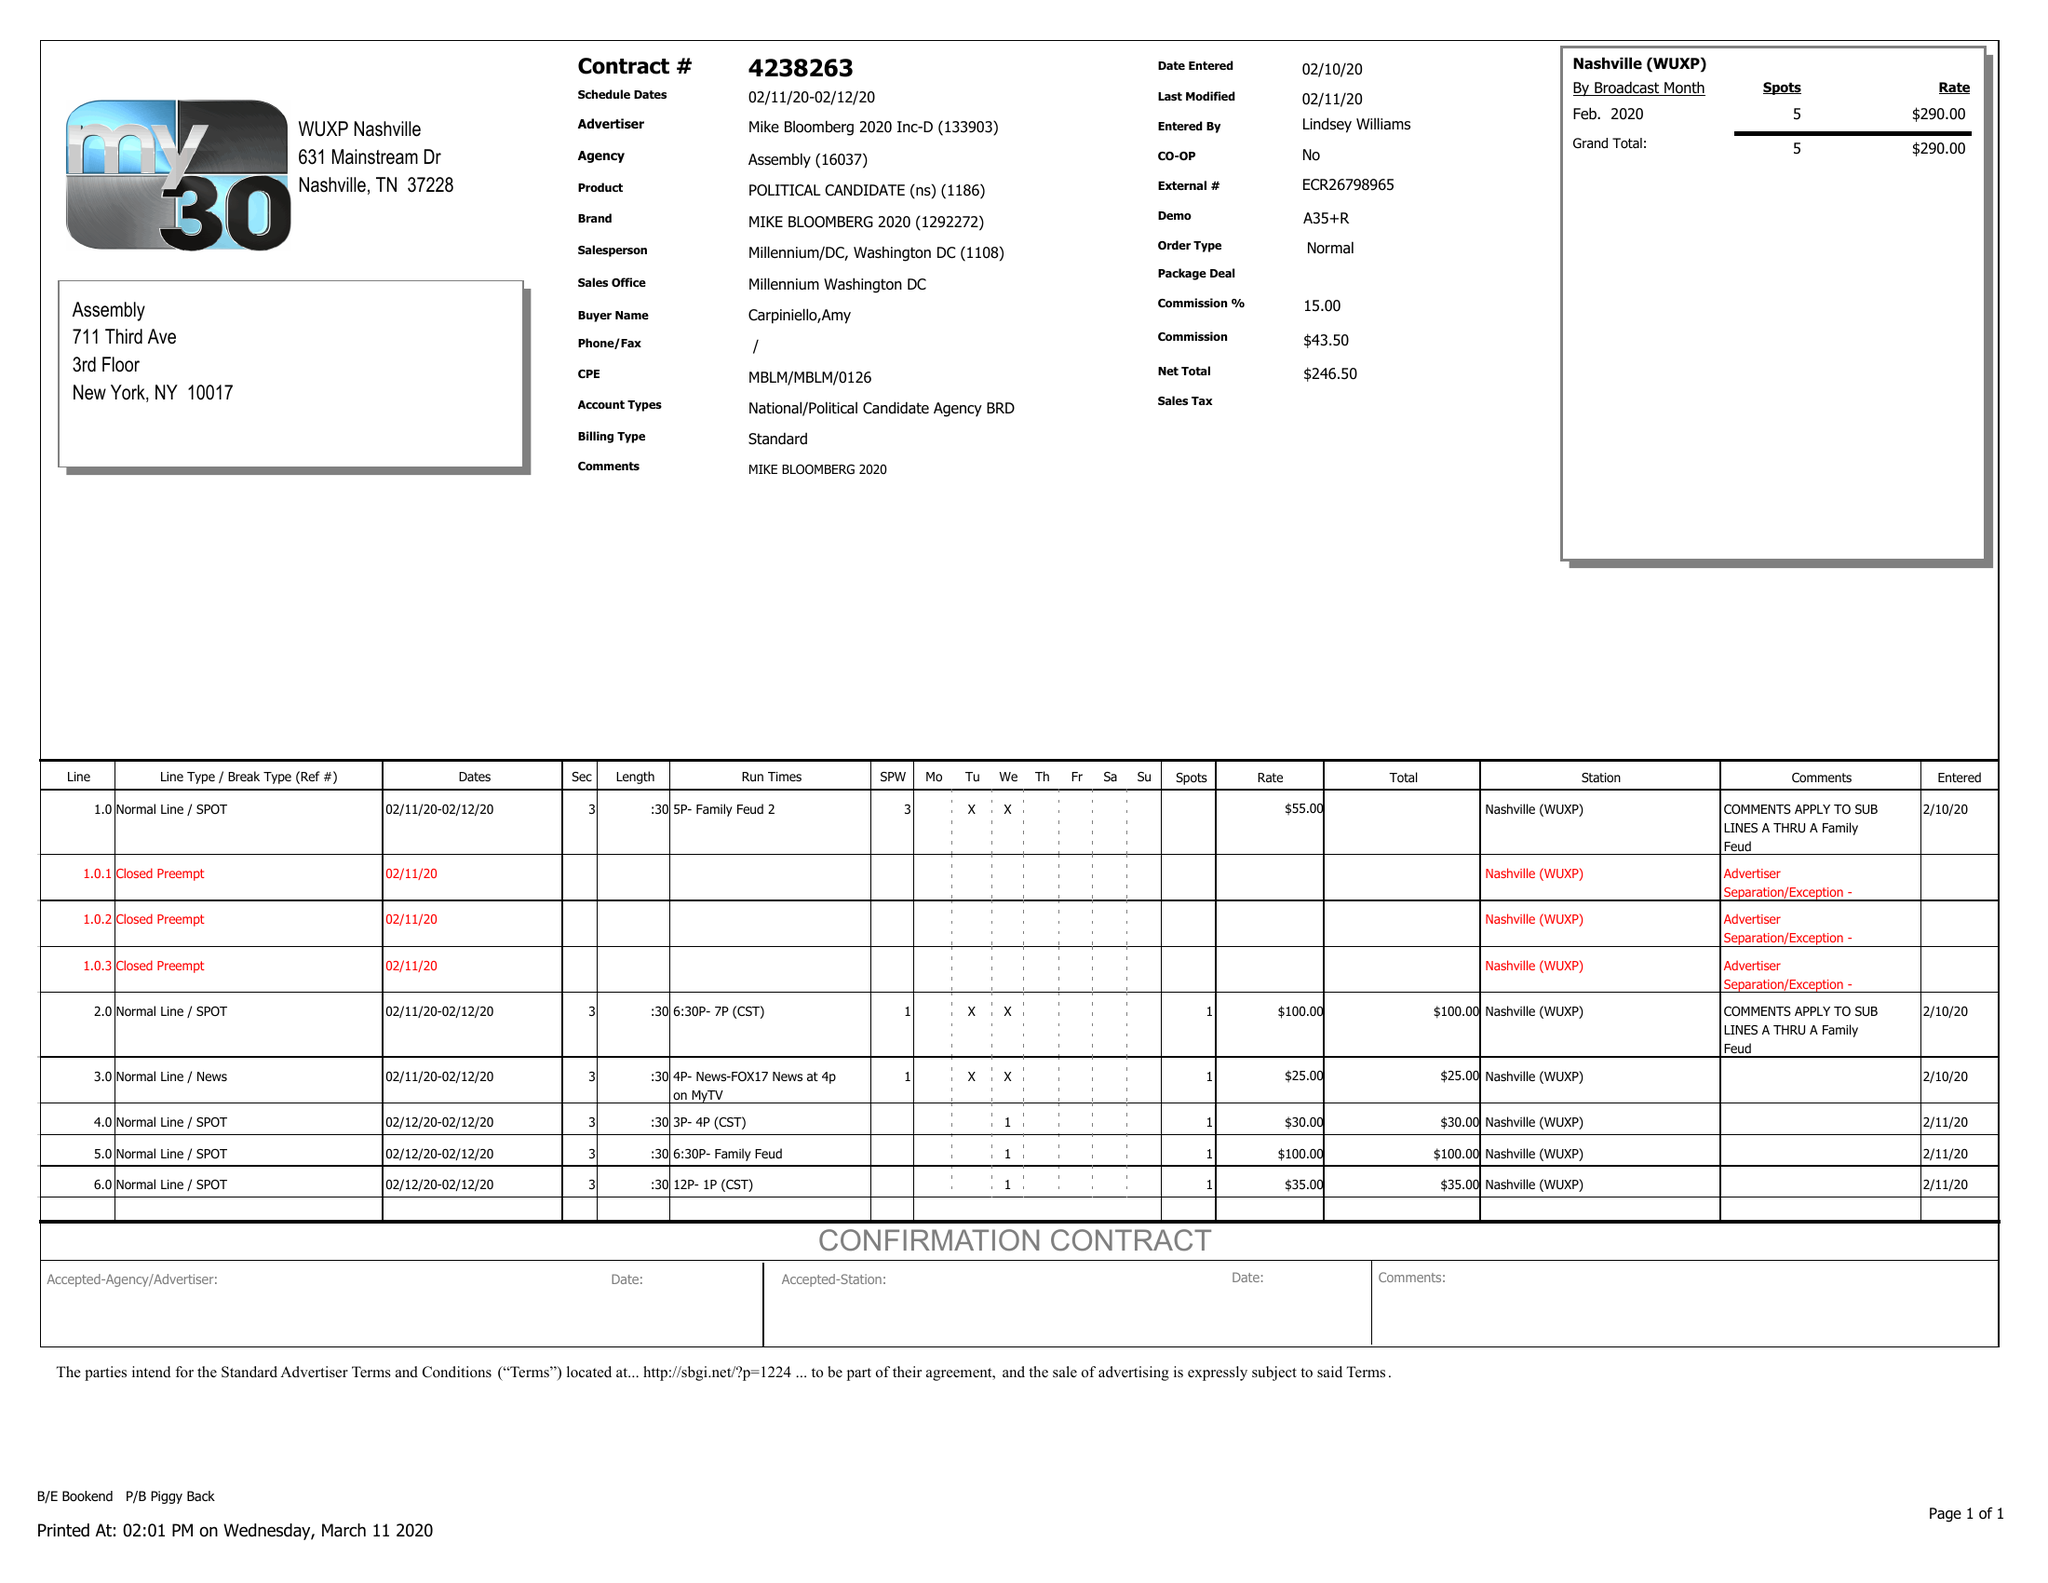What is the value for the contract_num?
Answer the question using a single word or phrase. 4238263 